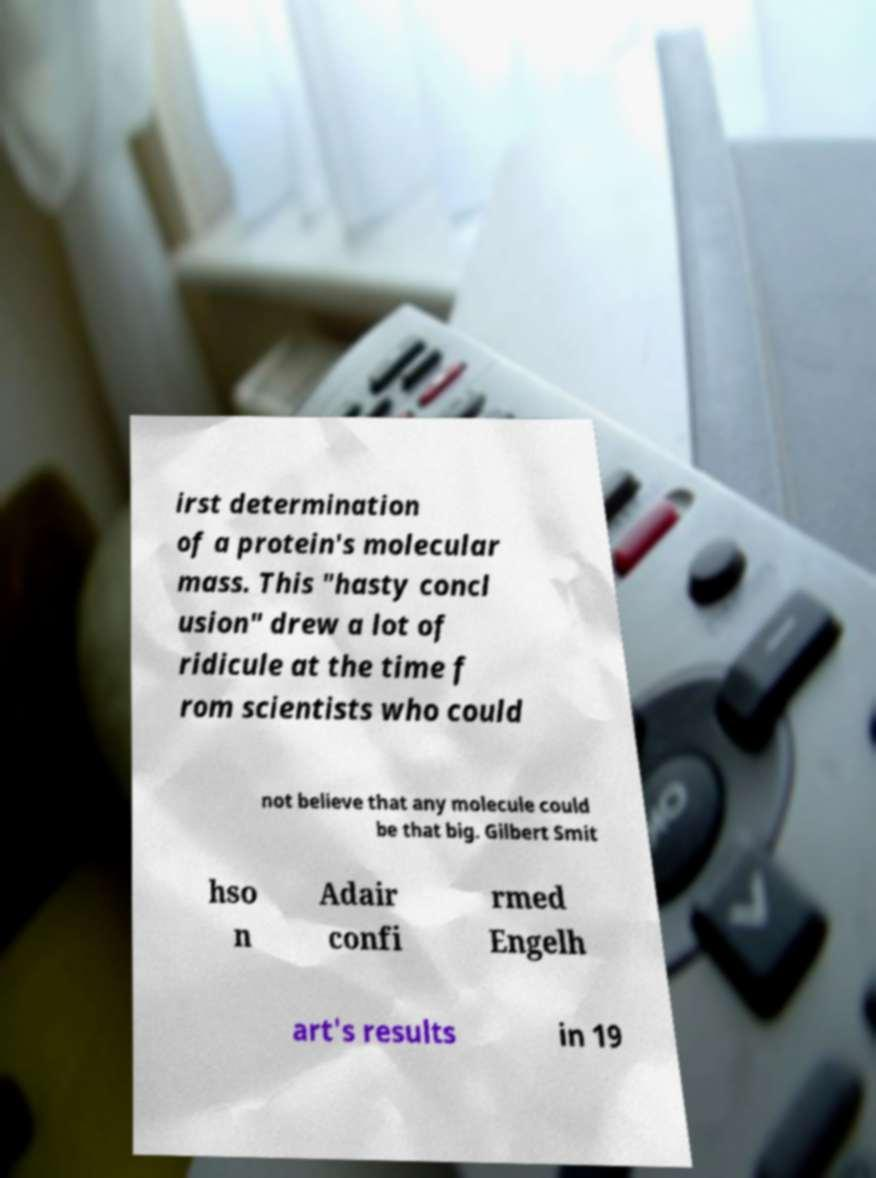Please identify and transcribe the text found in this image. irst determination of a protein's molecular mass. This "hasty concl usion" drew a lot of ridicule at the time f rom scientists who could not believe that any molecule could be that big. Gilbert Smit hso n Adair confi rmed Engelh art's results in 19 